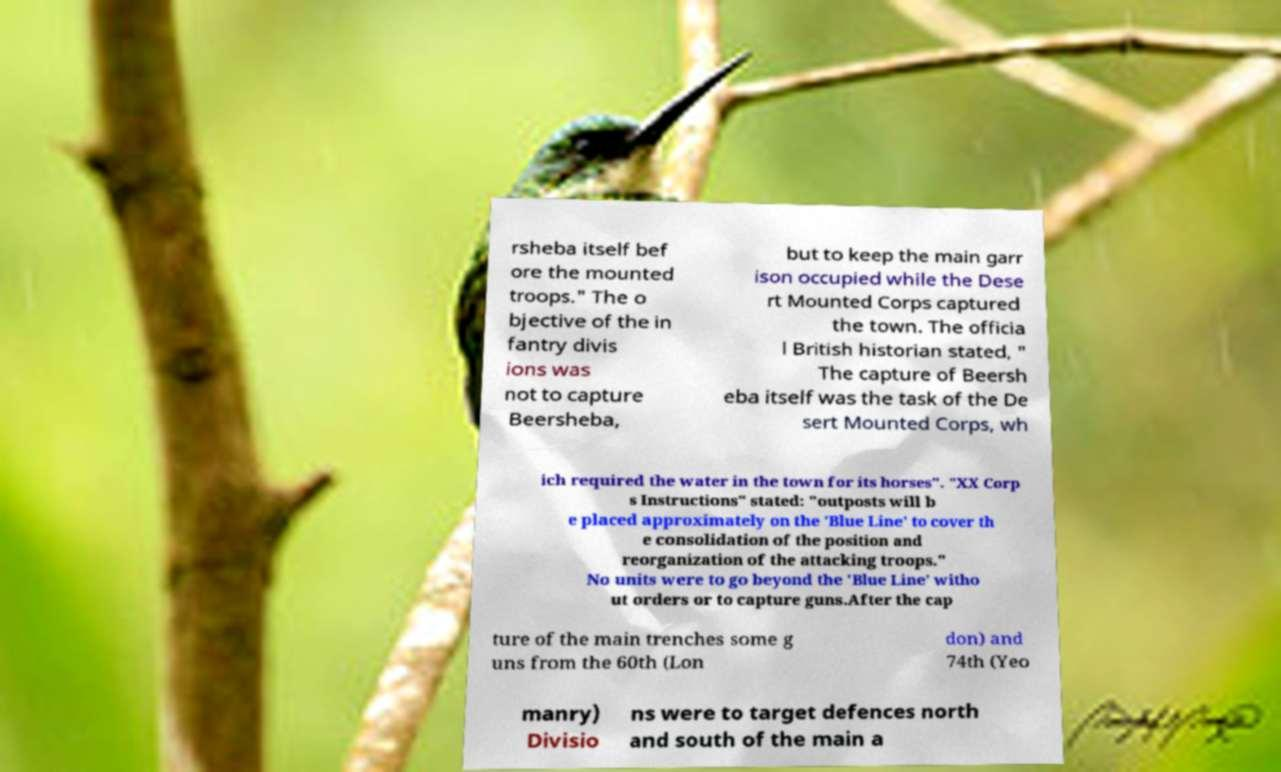Could you assist in decoding the text presented in this image and type it out clearly? rsheba itself bef ore the mounted troops." The o bjective of the in fantry divis ions was not to capture Beersheba, but to keep the main garr ison occupied while the Dese rt Mounted Corps captured the town. The officia l British historian stated, " The capture of Beersh eba itself was the task of the De sert Mounted Corps, wh ich required the water in the town for its horses". "XX Corp s Instructions" stated: "outposts will b e placed approximately on the 'Blue Line' to cover th e consolidation of the position and reorganization of the attacking troops." No units were to go beyond the 'Blue Line' witho ut orders or to capture guns.After the cap ture of the main trenches some g uns from the 60th (Lon don) and 74th (Yeo manry) Divisio ns were to target defences north and south of the main a 